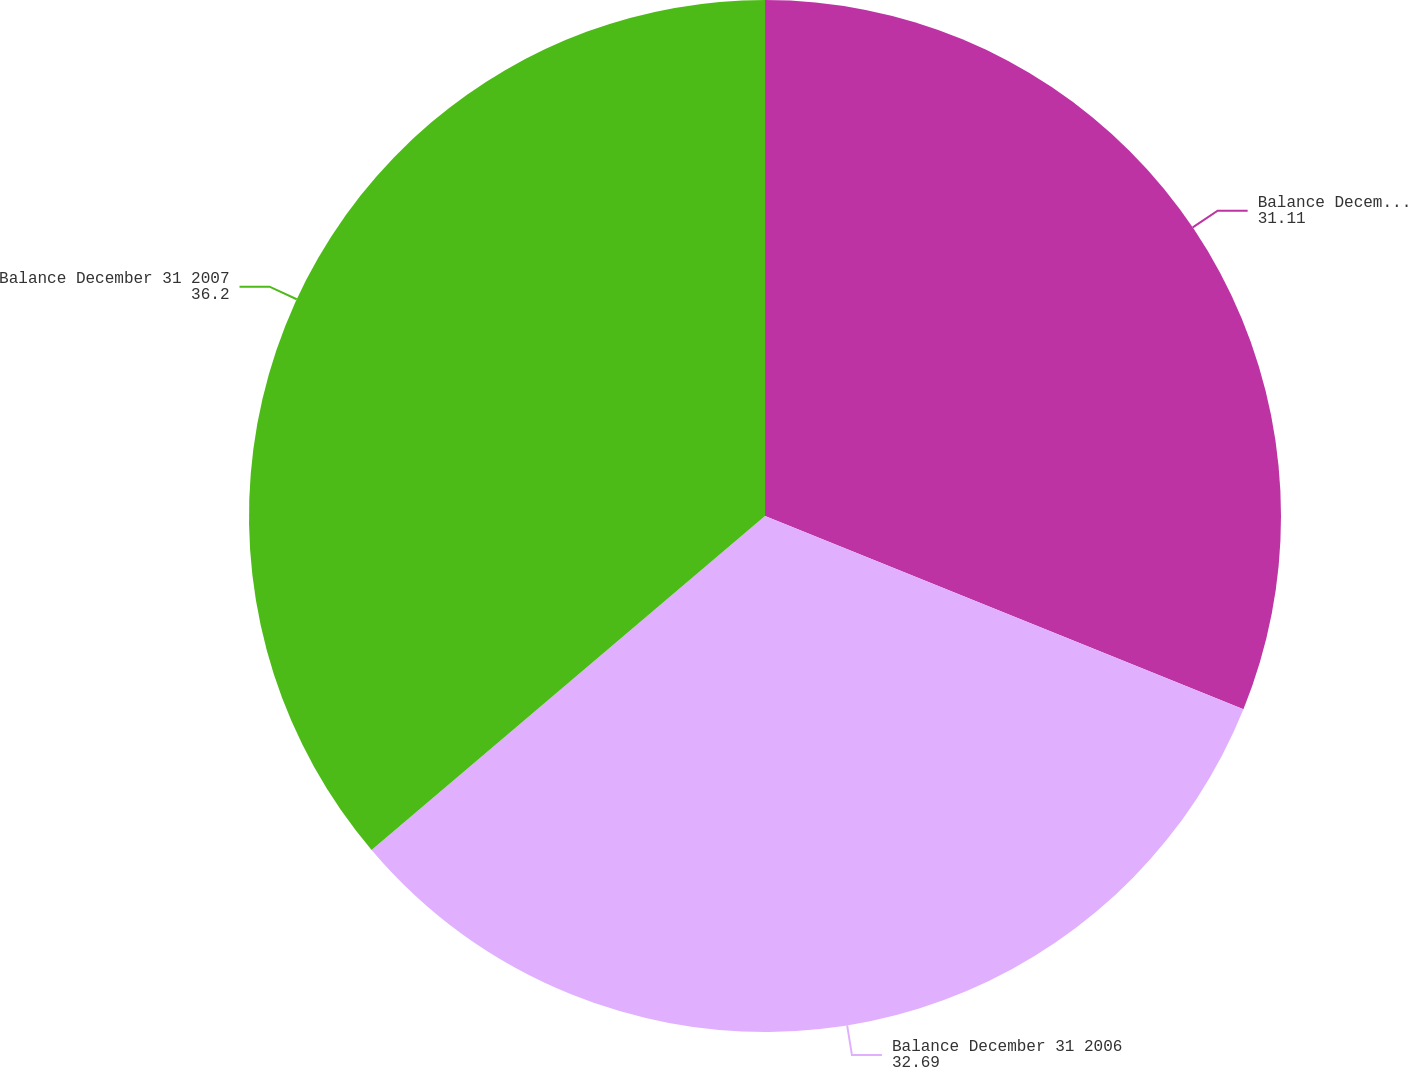Convert chart. <chart><loc_0><loc_0><loc_500><loc_500><pie_chart><fcel>Balance December 31 2005<fcel>Balance December 31 2006<fcel>Balance December 31 2007<nl><fcel>31.11%<fcel>32.69%<fcel>36.2%<nl></chart> 